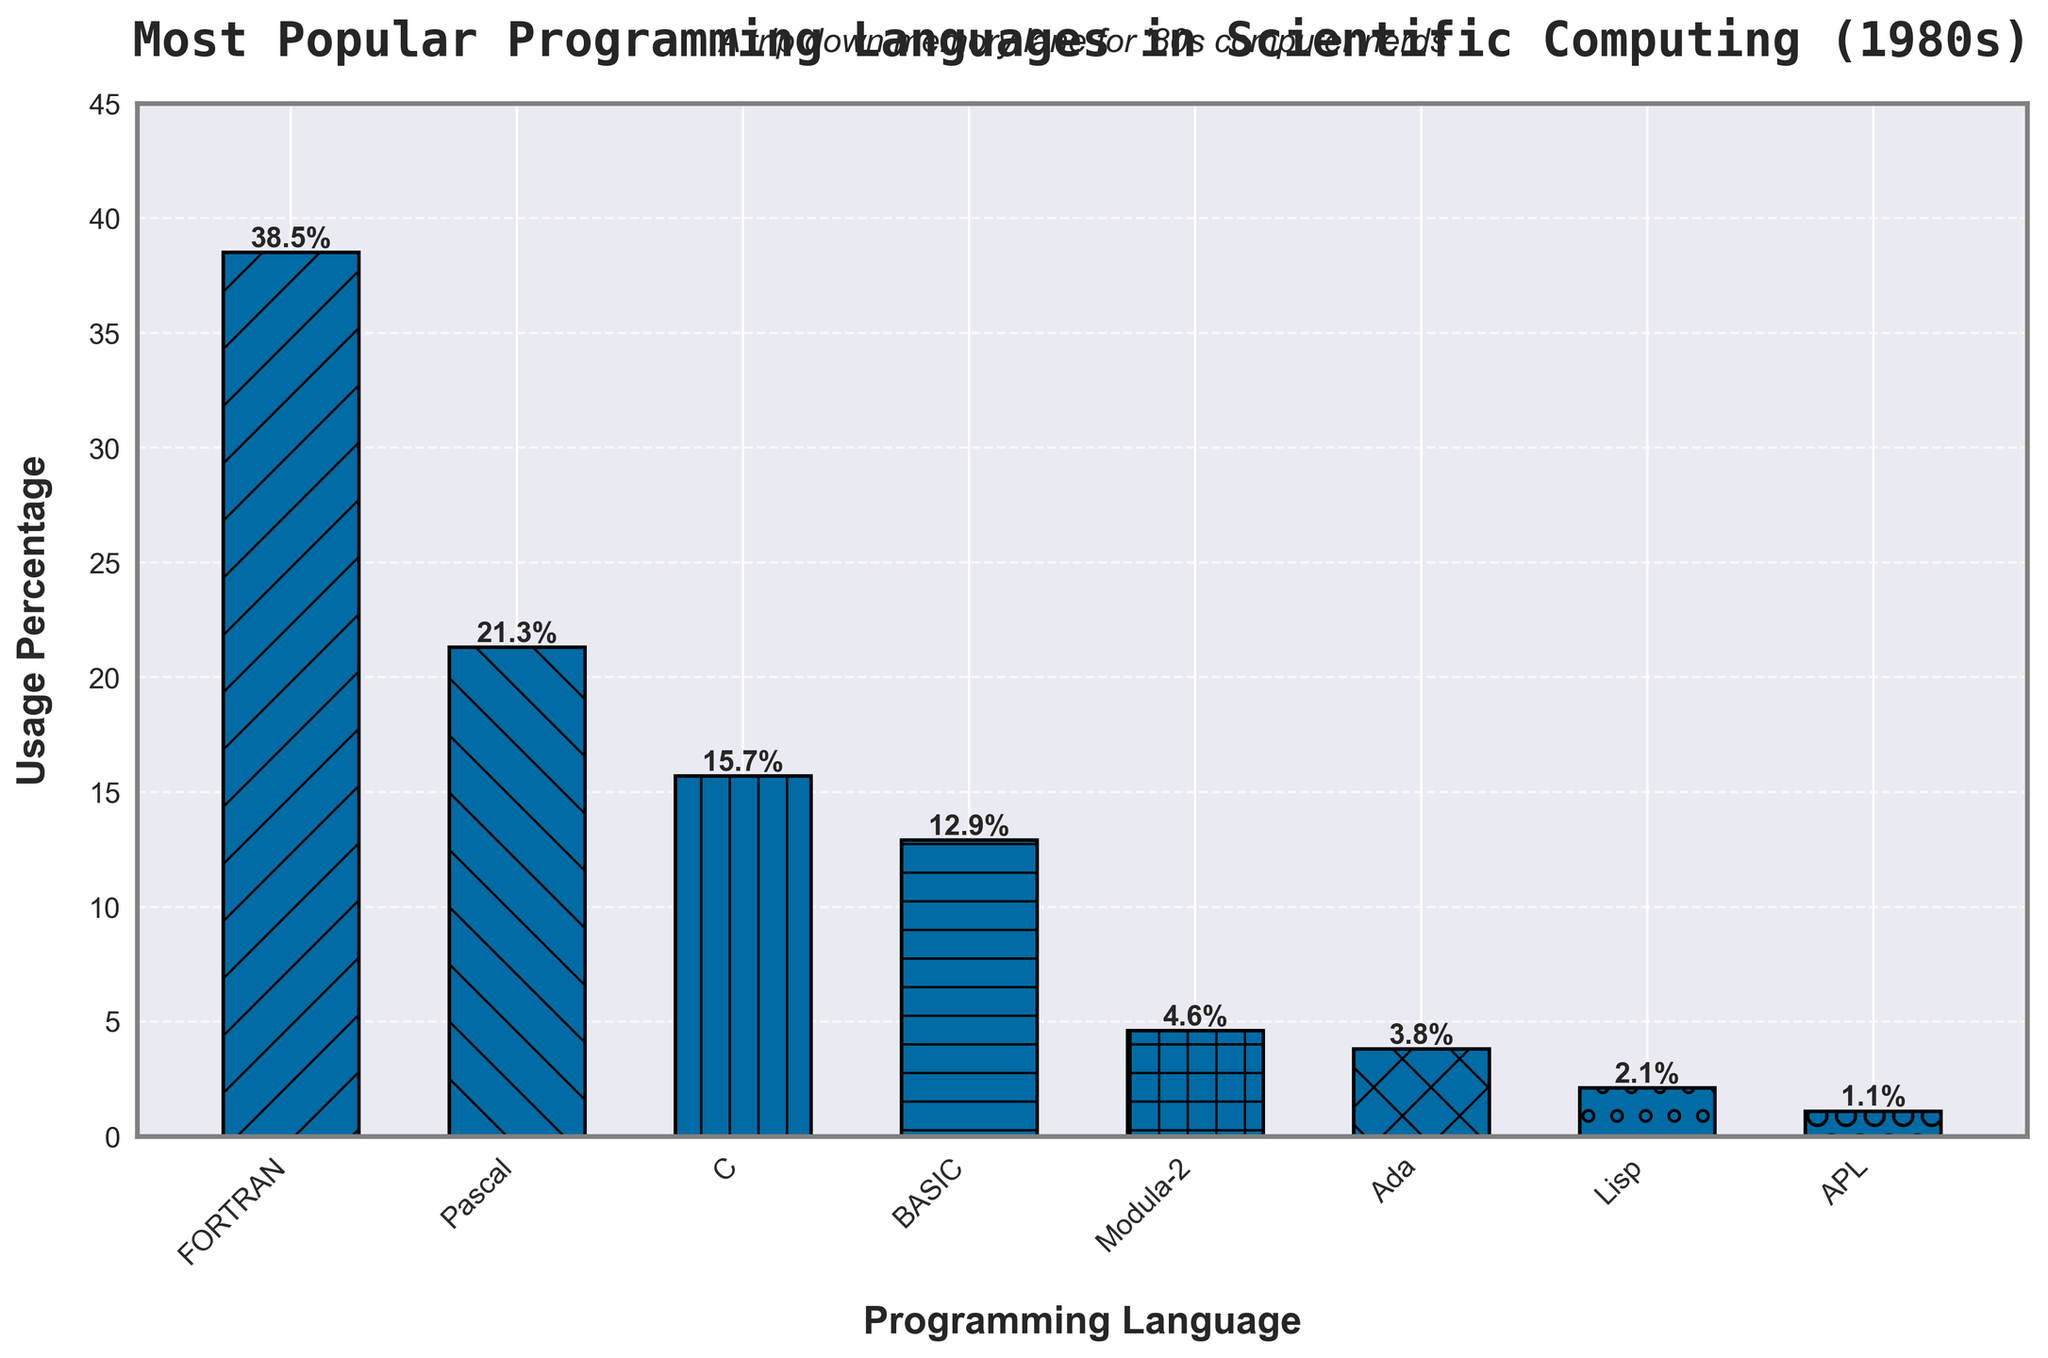Which programming language has the highest usage percentage in scientific computing during the 1980s? The bar chart shows different programming languages and their respective usage percentages. The tallest bar with the largest percentage corresponds to FORTRAN.
Answer: FORTRAN Compare the usage percentages of Pascal and C. Which one is higher, and by how much? By looking at the heights of the bars for Pascal and C, Pascal has a higher usage percentage. To find the difference, subtract C's percentage (15.7%) from Pascal's (21.3%).
Answer: Pascal by 5.6% What is the combined usage percentage of BASIC, Ada, and APL? Adding the usage percentages of BASIC (12.9%), Ada (3.8%), and APL (1.1%): 12.9 + 3.8 + 1.1 = 17.8%
Answer: 17.8% Which languages have usage percentages greater than 10%? By examining the chart, languages with usage percentages over 10% are FORTRAN (38.5%), Pascal (21.3%), C (15.7%), and BASIC (12.9%).
Answer: FORTRAN, Pascal, C, BASIC What is the average usage percentage of all the languages listed in the chart? Sum up all percentages and divide by the number of languages. (38.5 + 21.3 + 15.7 + 12.9 + 4.6 + 3.8 + 2.1 + 1.1) / 8 = 100 / 8 = 12.5%
Answer: 12.5% How much higher is FORTRAN's usage percentage compared to Modula-2? Subtract Modula-2's percentage (4.6%) from FORTRAN’s (38.5%): 38.5 - 4.6 = 33.9%
Answer: 33.9% Are there any languages with usage percentages less than 5%? If so, which ones? Checking the chart, the languages with usage percentages less than 5% are Modula-2 (4.6%), Ada (3.8%), Lisp (2.1%), and APL (1.1%).
Answer: Modula-2, Ada, Lisp, APL What is the difference in usage percentage between the most popular and least popular language? The most popular language is FORTRAN (38.5%) and the least popular is APL (1.1%). The difference is 38.5 - 1.1 = 37.4%.
Answer: 37.4% Among the languages with single-digit usage percentages, which language has the highest usage? The single-digit usage percentages are Modula-2 (4.6%), Ada (3.8%), Lisp (2.1%), and APL (1.1%). The highest among these is Modula-2.
Answer: Modula-2 